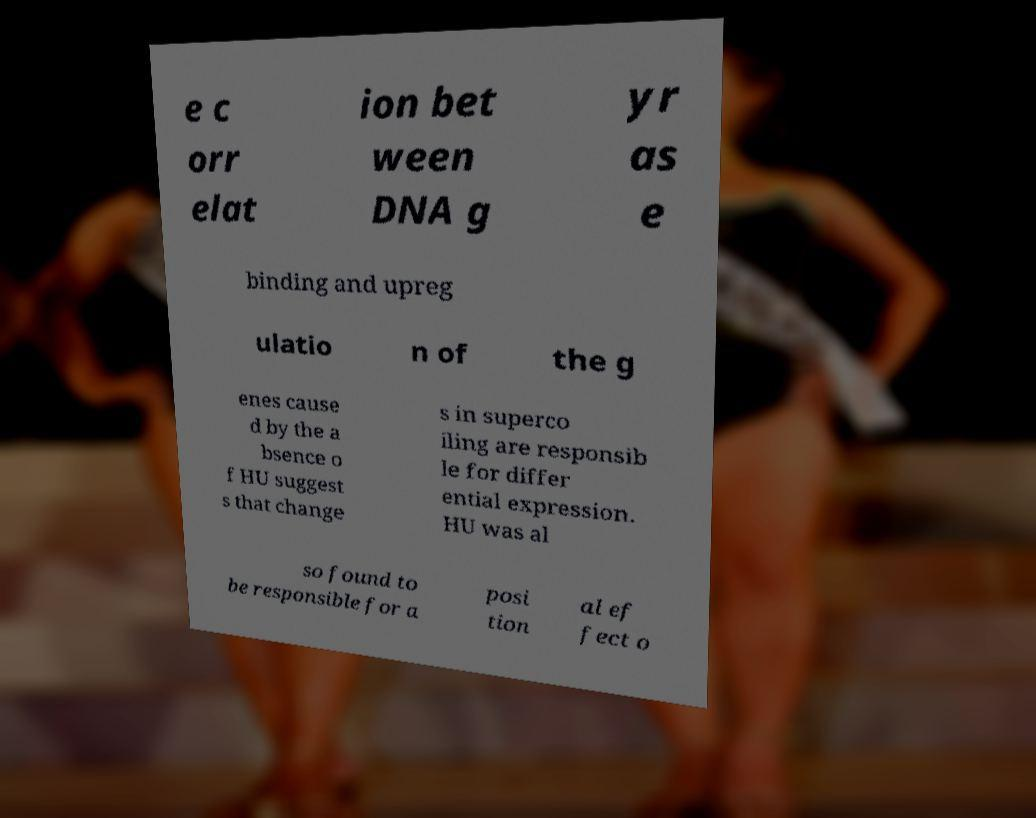Can you accurately transcribe the text from the provided image for me? e c orr elat ion bet ween DNA g yr as e binding and upreg ulatio n of the g enes cause d by the a bsence o f HU suggest s that change s in superco iling are responsib le for differ ential expression. HU was al so found to be responsible for a posi tion al ef fect o 